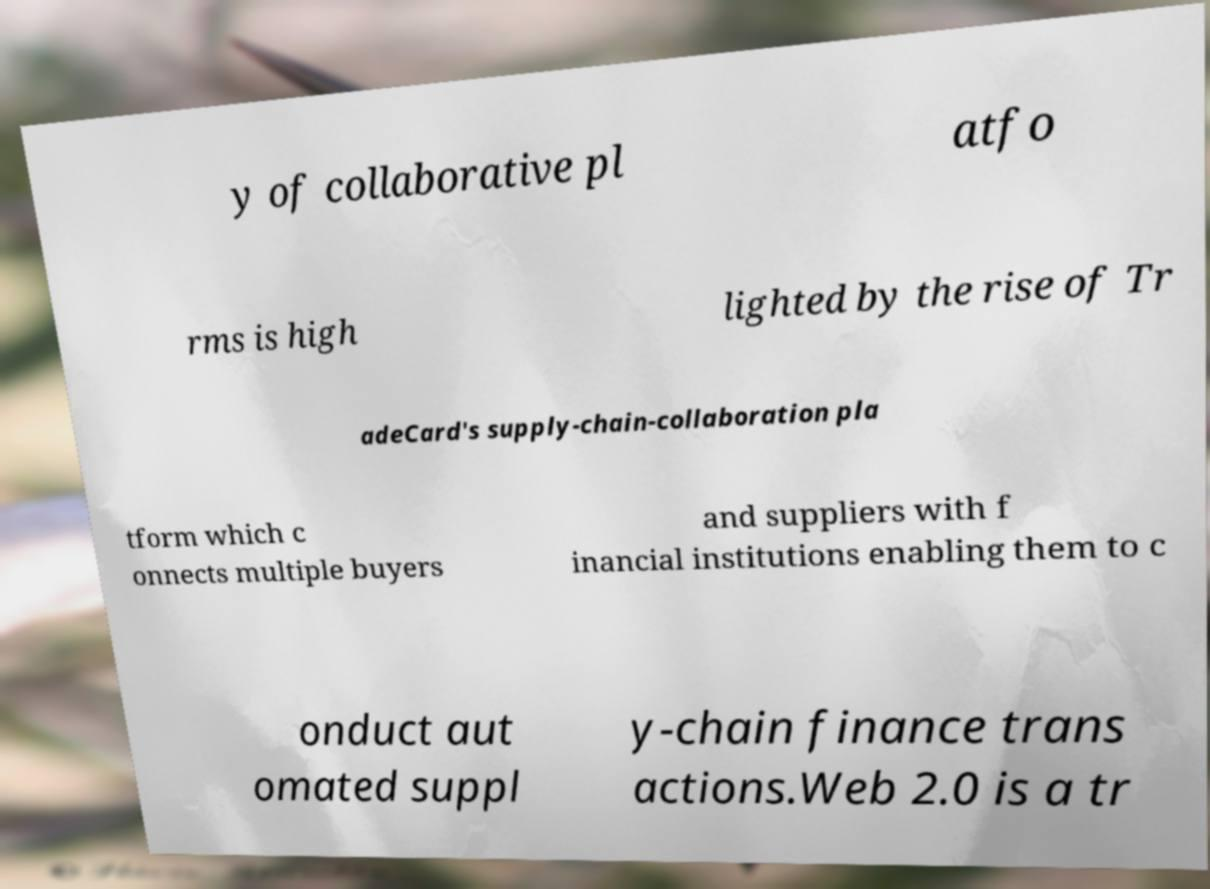What messages or text are displayed in this image? I need them in a readable, typed format. y of collaborative pl atfo rms is high lighted by the rise of Tr adeCard's supply-chain-collaboration pla tform which c onnects multiple buyers and suppliers with f inancial institutions enabling them to c onduct aut omated suppl y-chain finance trans actions.Web 2.0 is a tr 